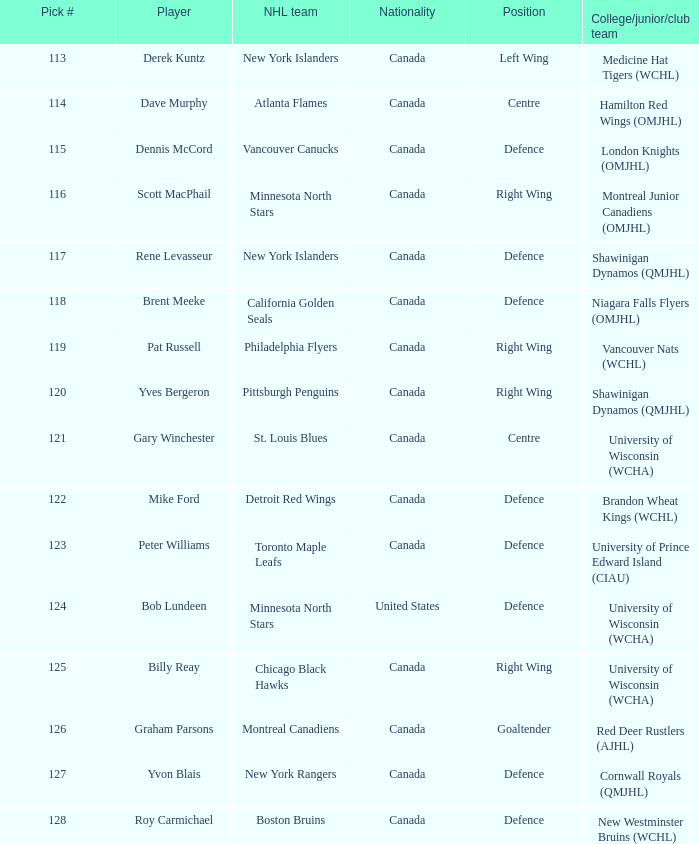Name the player for chicago black hawks Billy Reay. 